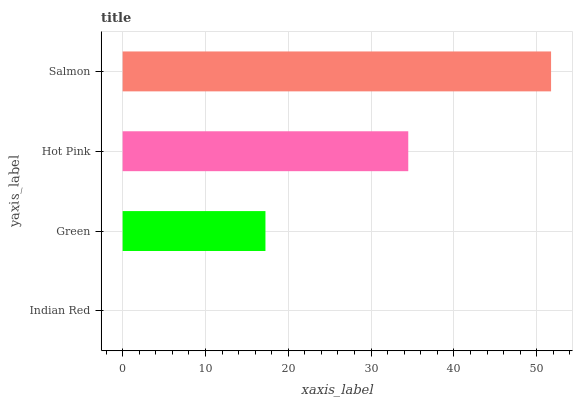Is Indian Red the minimum?
Answer yes or no. Yes. Is Salmon the maximum?
Answer yes or no. Yes. Is Green the minimum?
Answer yes or no. No. Is Green the maximum?
Answer yes or no. No. Is Green greater than Indian Red?
Answer yes or no. Yes. Is Indian Red less than Green?
Answer yes or no. Yes. Is Indian Red greater than Green?
Answer yes or no. No. Is Green less than Indian Red?
Answer yes or no. No. Is Hot Pink the high median?
Answer yes or no. Yes. Is Green the low median?
Answer yes or no. Yes. Is Indian Red the high median?
Answer yes or no. No. Is Hot Pink the low median?
Answer yes or no. No. 